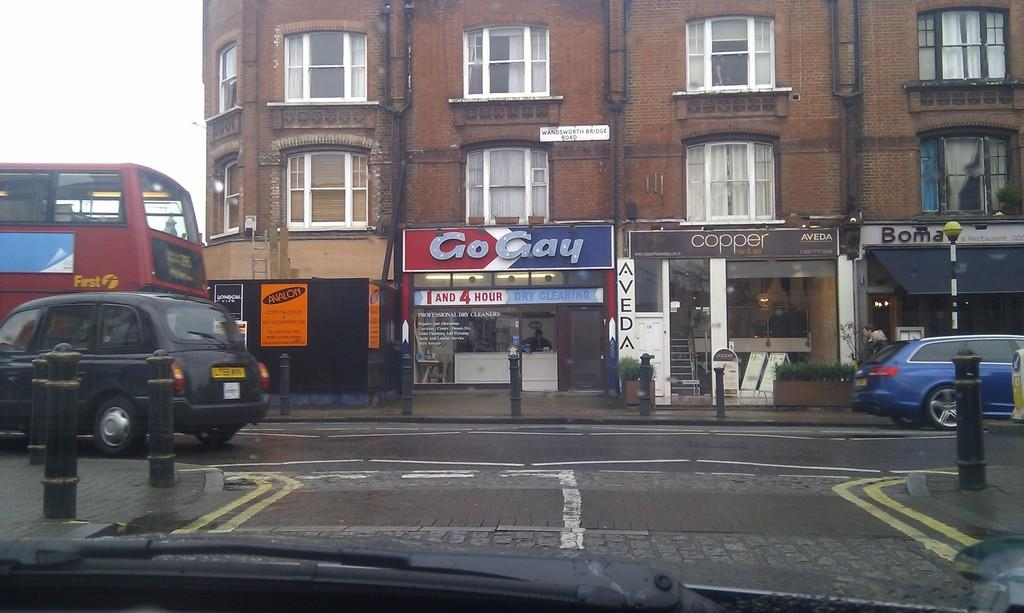<image>
Write a terse but informative summary of the picture. City buildings with a Go Gay store underneath. 